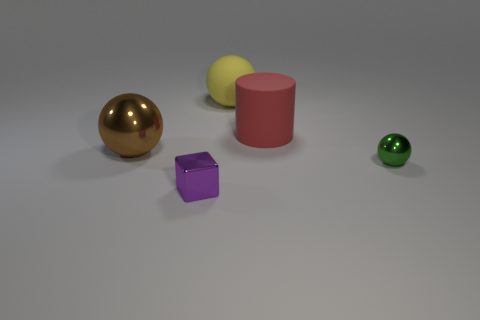There is a large metallic object; is its color the same as the ball in front of the brown ball?
Ensure brevity in your answer.  No. How many large rubber spheres are behind the tiny green sphere?
Ensure brevity in your answer.  1. Are there fewer yellow objects than red metallic cylinders?
Make the answer very short. No. There is a sphere that is both right of the cube and in front of the yellow sphere; what size is it?
Your answer should be very brief. Small. There is a shiny object that is behind the green metal thing; does it have the same color as the large matte sphere?
Offer a terse response. No. Is the number of large rubber cylinders that are on the right side of the red rubber object less than the number of yellow cylinders?
Offer a very short reply. No. The small green thing that is made of the same material as the big brown sphere is what shape?
Provide a short and direct response. Sphere. Is the material of the tiny purple thing the same as the large yellow object?
Offer a very short reply. No. Are there fewer green metal balls that are to the right of the tiny green ball than large brown metallic objects in front of the small metal cube?
Your answer should be compact. No. What number of green balls are on the left side of the sphere in front of the large thing on the left side of the large matte ball?
Keep it short and to the point. 0. 